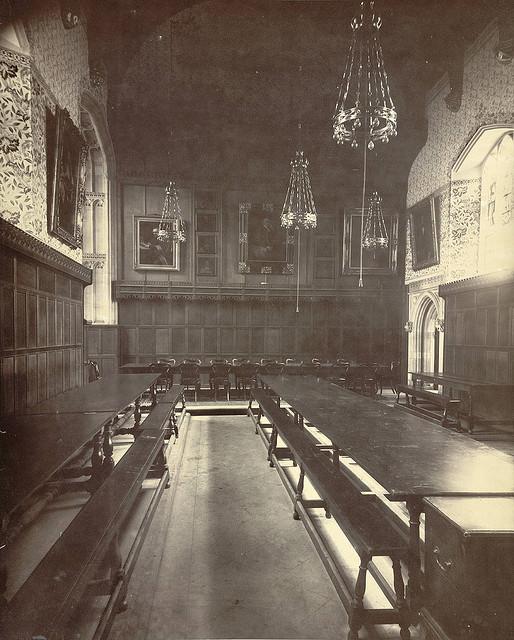About how many people would this cafeteria seat?
Be succinct. 50. Could this be a boarding school cafeteria?
Quick response, please. Yes. Is there a bench for every table?
Short answer required. Yes. Are there chairs at the table?
Short answer required. No. 